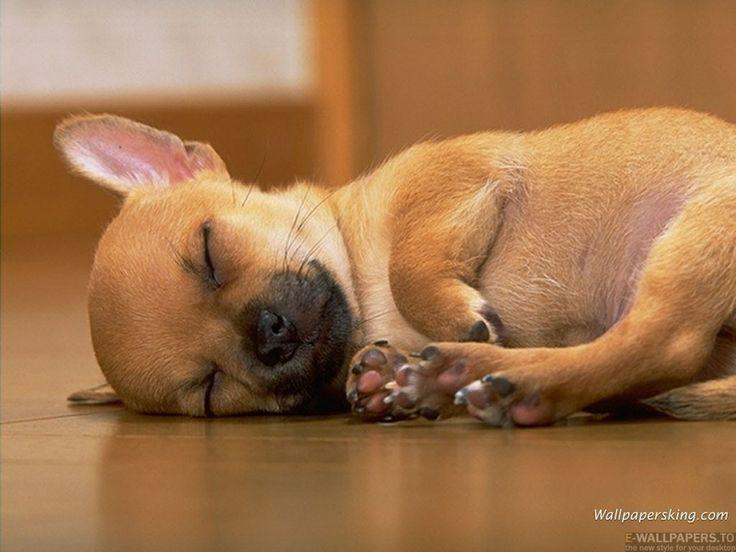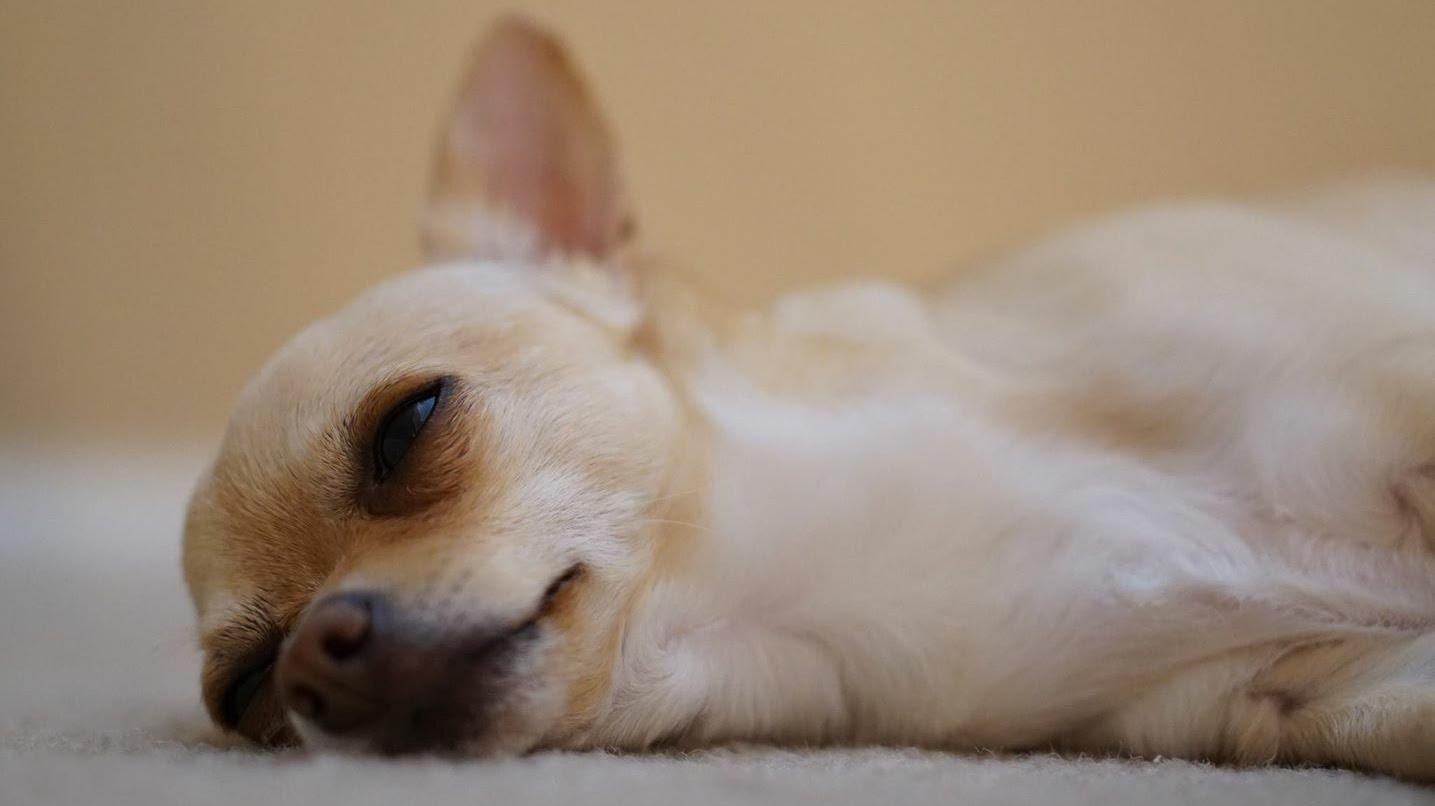The first image is the image on the left, the second image is the image on the right. Assess this claim about the two images: "The eyes of the dog in the image on the right are half open.". Correct or not? Answer yes or no. Yes. The first image is the image on the left, the second image is the image on the right. Considering the images on both sides, is "Both images show a chihuahua dog in a snoozing pose, but only one dog has its eyes completely shut." valid? Answer yes or no. Yes. 